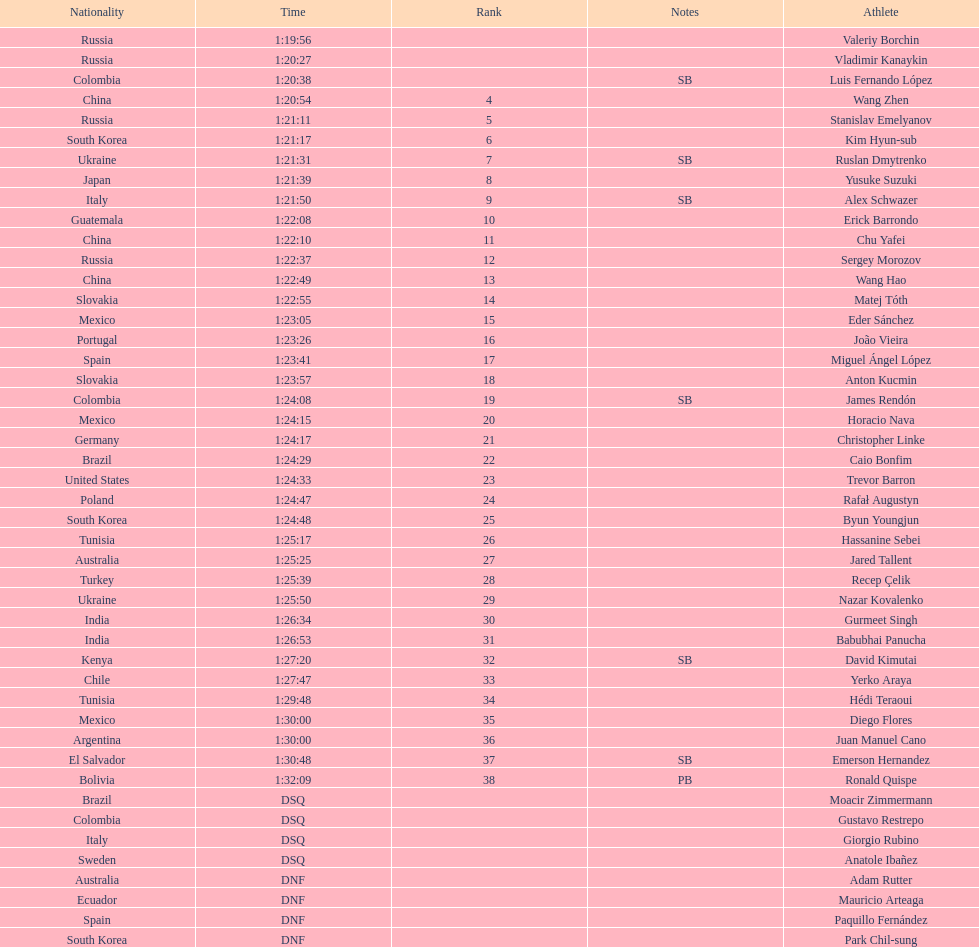Name all athletes were slower than horacio nava. Christopher Linke, Caio Bonfim, Trevor Barron, Rafał Augustyn, Byun Youngjun, Hassanine Sebei, Jared Tallent, Recep Çelik, Nazar Kovalenko, Gurmeet Singh, Babubhai Panucha, David Kimutai, Yerko Araya, Hédi Teraoui, Diego Flores, Juan Manuel Cano, Emerson Hernandez, Ronald Quispe. 